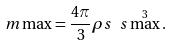Convert formula to latex. <formula><loc_0><loc_0><loc_500><loc_500>\ m \max = \frac { 4 \pi } { 3 } \rho s \ s \max ^ { 3 } .</formula> 